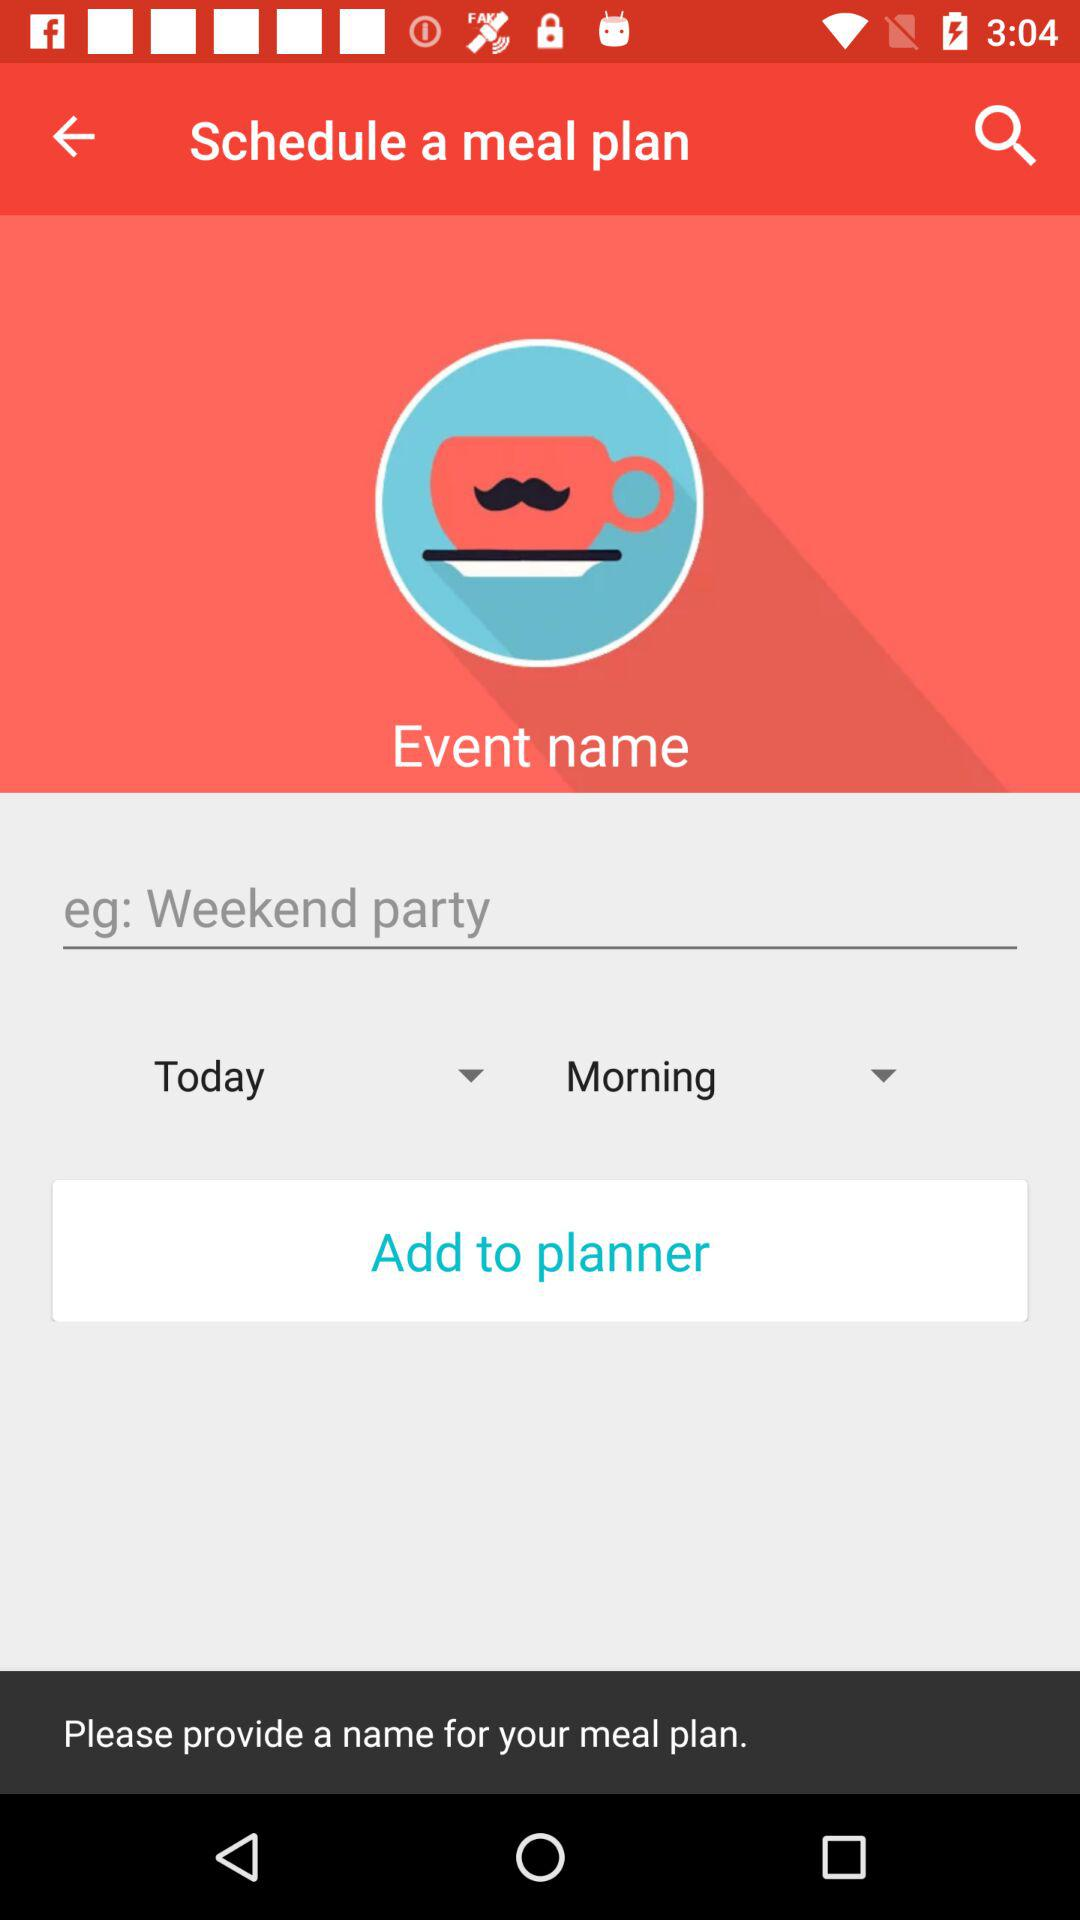What is the selected time zone?
When the provided information is insufficient, respond with <no answer>. <no answer> 